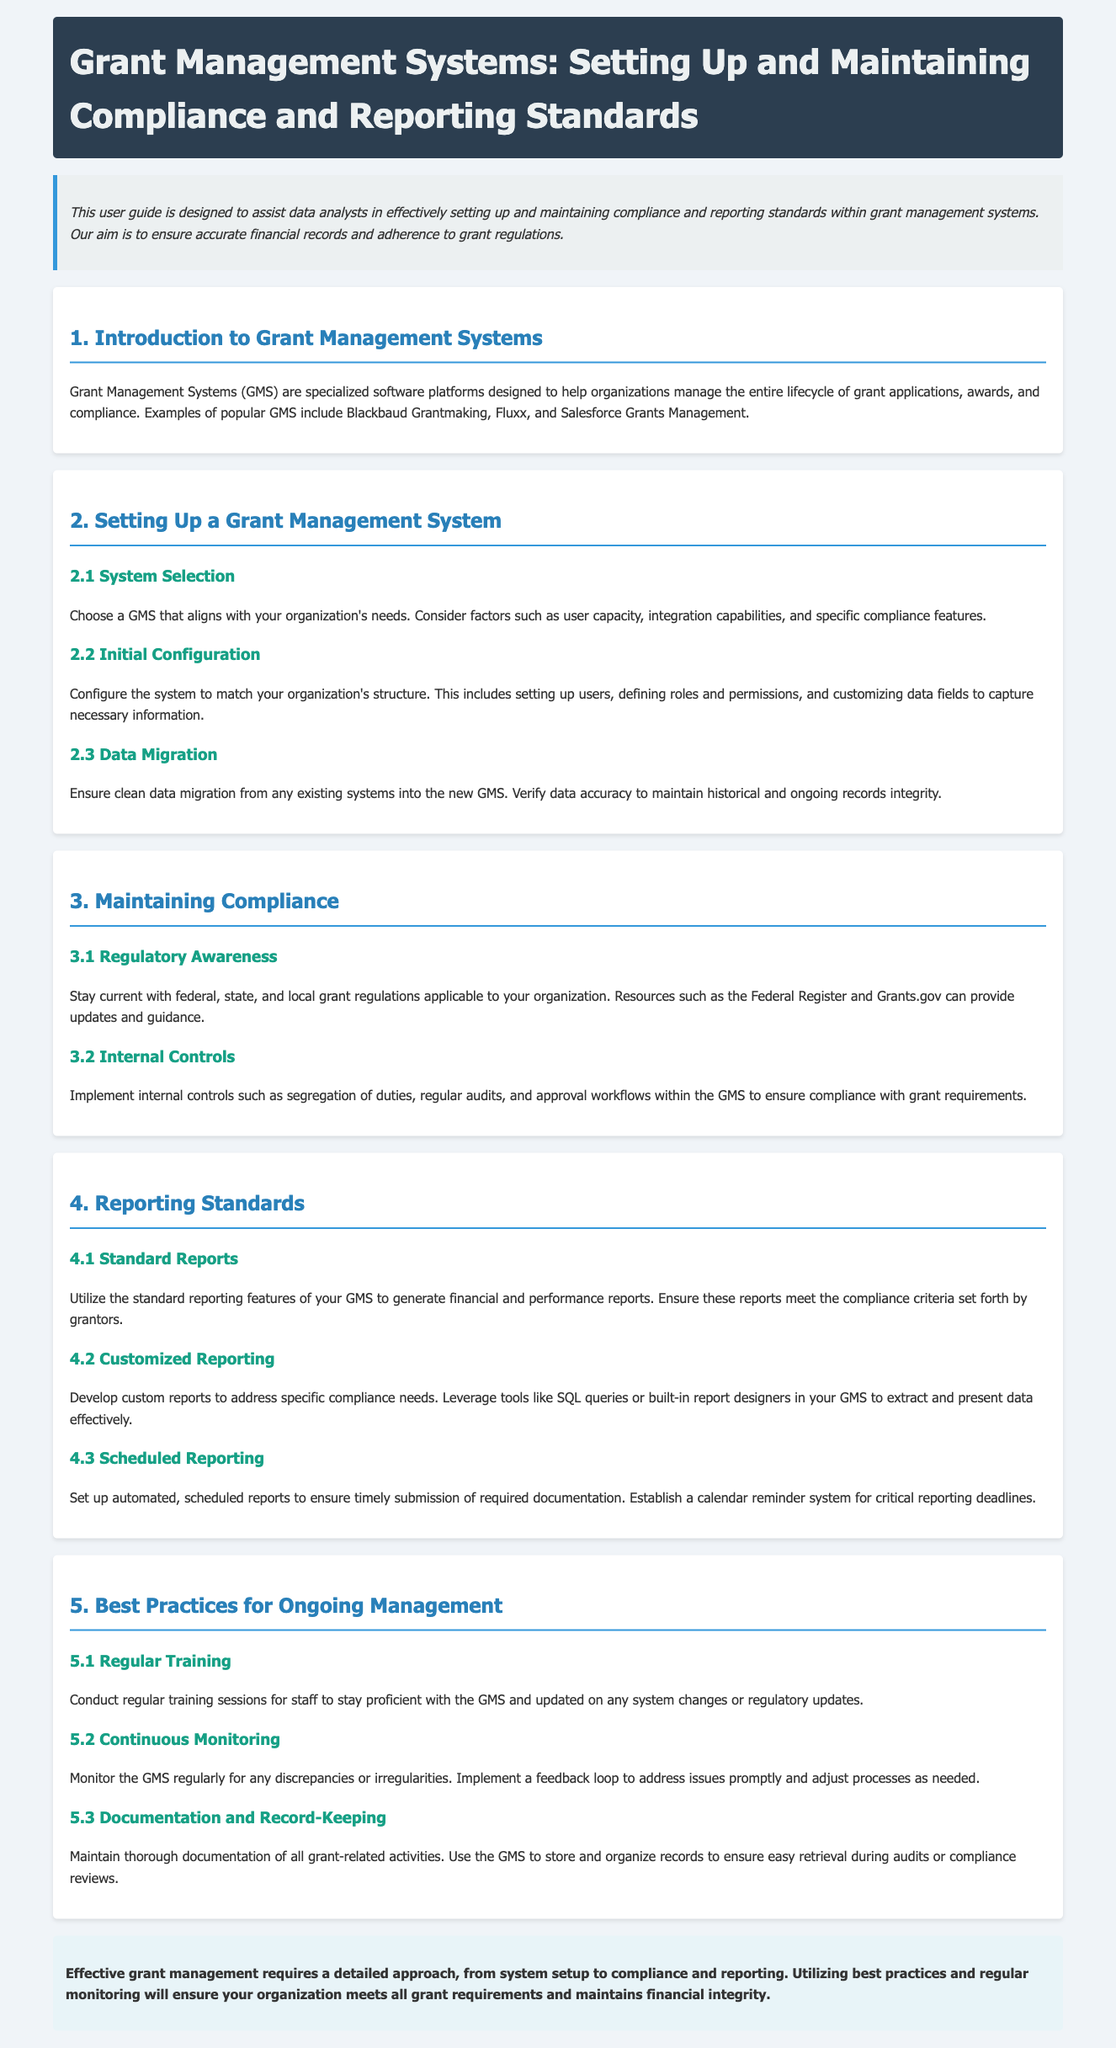What are examples of popular Grant Management Systems? The document lists examples of popular Grant Management Systems, which include Blackbaud Grantmaking, Fluxx, and Salesforce Grants Management.
Answer: Blackbaud Grantmaking, Fluxx, Salesforce Grants Management What should be considered during system selection? The document mentions that factors such as user capacity, integration capabilities, and specific compliance features should be considered during system selection.
Answer: User capacity, integration capabilities, specific compliance features Which regulatory resources can provide updates? The document states that resources such as the Federal Register and Grants.gov can provide updates and guidance on grant regulations.
Answer: Federal Register, Grants.gov What is one of the internal controls mentioned for compliance? The document indicates that implementing segregation of duties is one of the internal controls recommended for ensuring compliance with grant requirements.
Answer: Segregation of duties What is a best practice for ongoing management? The document suggests conducting regular training sessions for staff as a best practice for ongoing management of the Grant Management System.
Answer: Regular training Which feature allows generating financial reports? The standard reporting features of the Grant Management System are mentioned as a way to generate financial and performance reports.
Answer: Standard reporting features What is the aim of this user guide? The document states that the aim is to assist data analysts in effectively setting up and maintaining compliance and reporting standards within grant management systems.
Answer: Assist data analysts What should be maintained for all grant-related activities? It is stated in the document that thorough documentation of all grant-related activities should be maintained for effective grant management.
Answer: Documentation 